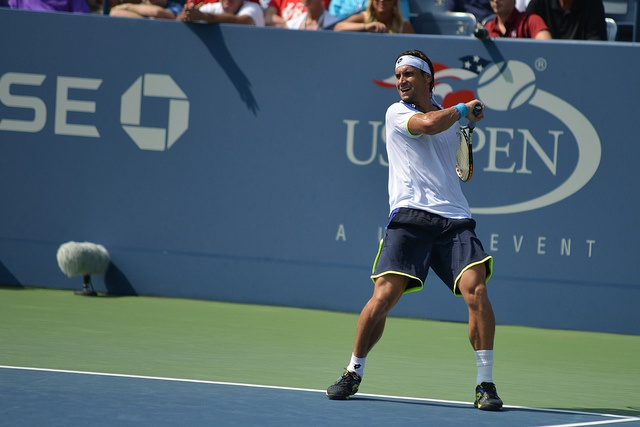Describe the objects in this image and their specific colors. I can see people in navy, black, lightgray, gray, and maroon tones, people in navy, black, teal, and maroon tones, people in navy, black, maroon, and gray tones, people in navy, black, maroon, and brown tones, and people in navy, black, maroon, gray, and tan tones in this image. 